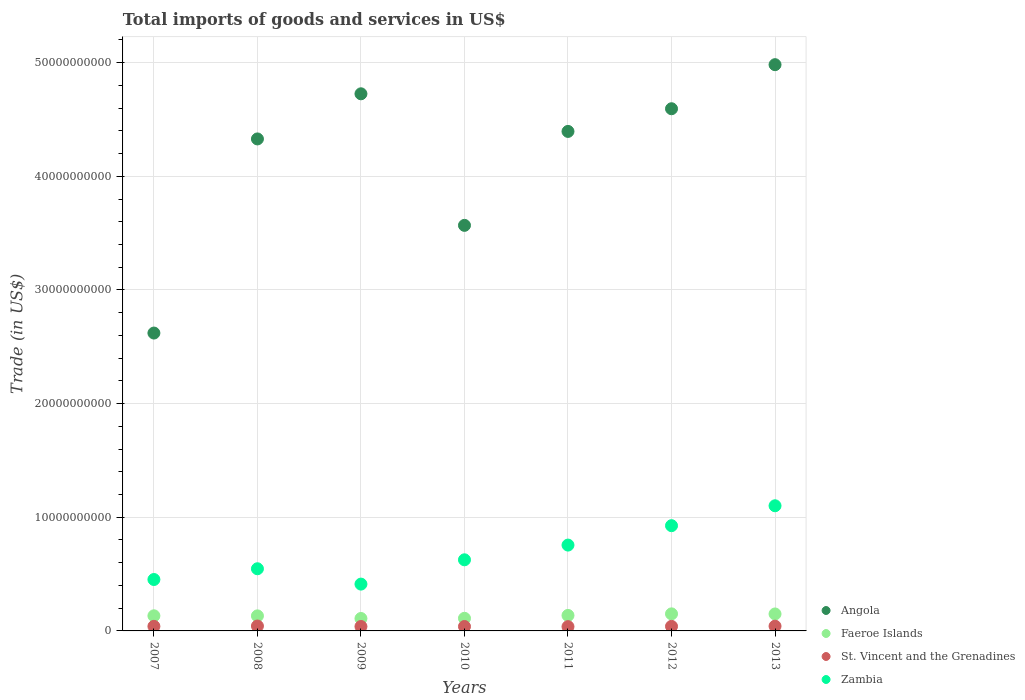Is the number of dotlines equal to the number of legend labels?
Make the answer very short. Yes. What is the total imports of goods and services in Angola in 2012?
Your answer should be very brief. 4.59e+1. Across all years, what is the maximum total imports of goods and services in Faeroe Islands?
Your answer should be compact. 1.50e+09. Across all years, what is the minimum total imports of goods and services in St. Vincent and the Grenadines?
Keep it short and to the point. 3.77e+08. What is the total total imports of goods and services in Zambia in the graph?
Give a very brief answer. 4.82e+1. What is the difference between the total imports of goods and services in Zambia in 2008 and that in 2013?
Your response must be concise. -5.54e+09. What is the difference between the total imports of goods and services in Zambia in 2011 and the total imports of goods and services in Angola in 2010?
Keep it short and to the point. -2.81e+1. What is the average total imports of goods and services in Faeroe Islands per year?
Offer a very short reply. 1.32e+09. In the year 2010, what is the difference between the total imports of goods and services in Faeroe Islands and total imports of goods and services in St. Vincent and the Grenadines?
Give a very brief answer. 7.22e+08. What is the ratio of the total imports of goods and services in Zambia in 2010 to that in 2011?
Offer a very short reply. 0.83. Is the difference between the total imports of goods and services in Faeroe Islands in 2009 and 2010 greater than the difference between the total imports of goods and services in St. Vincent and the Grenadines in 2009 and 2010?
Make the answer very short. No. What is the difference between the highest and the second highest total imports of goods and services in Faeroe Islands?
Provide a succinct answer. 8.29e+06. What is the difference between the highest and the lowest total imports of goods and services in Faeroe Islands?
Your answer should be very brief. 4.08e+08. In how many years, is the total imports of goods and services in St. Vincent and the Grenadines greater than the average total imports of goods and services in St. Vincent and the Grenadines taken over all years?
Give a very brief answer. 4. Is the sum of the total imports of goods and services in Angola in 2008 and 2009 greater than the maximum total imports of goods and services in St. Vincent and the Grenadines across all years?
Your response must be concise. Yes. Is the total imports of goods and services in Faeroe Islands strictly greater than the total imports of goods and services in Zambia over the years?
Your response must be concise. No. Is the total imports of goods and services in Zambia strictly less than the total imports of goods and services in St. Vincent and the Grenadines over the years?
Offer a terse response. No. What is the difference between two consecutive major ticks on the Y-axis?
Keep it short and to the point. 1.00e+1. Does the graph contain any zero values?
Your response must be concise. No. Where does the legend appear in the graph?
Offer a terse response. Bottom right. How are the legend labels stacked?
Make the answer very short. Vertical. What is the title of the graph?
Keep it short and to the point. Total imports of goods and services in US$. Does "Paraguay" appear as one of the legend labels in the graph?
Ensure brevity in your answer.  No. What is the label or title of the Y-axis?
Keep it short and to the point. Trade (in US$). What is the Trade (in US$) of Angola in 2007?
Keep it short and to the point. 2.62e+1. What is the Trade (in US$) of Faeroe Islands in 2007?
Your answer should be very brief. 1.33e+09. What is the Trade (in US$) in St. Vincent and the Grenadines in 2007?
Your answer should be very brief. 4.02e+08. What is the Trade (in US$) in Zambia in 2007?
Your answer should be compact. 4.52e+09. What is the Trade (in US$) in Angola in 2008?
Provide a short and direct response. 4.33e+1. What is the Trade (in US$) in Faeroe Islands in 2008?
Ensure brevity in your answer.  1.32e+09. What is the Trade (in US$) in St. Vincent and the Grenadines in 2008?
Your answer should be compact. 4.31e+08. What is the Trade (in US$) of Zambia in 2008?
Ensure brevity in your answer.  5.47e+09. What is the Trade (in US$) of Angola in 2009?
Give a very brief answer. 4.73e+1. What is the Trade (in US$) in Faeroe Islands in 2009?
Offer a terse response. 1.09e+09. What is the Trade (in US$) in St. Vincent and the Grenadines in 2009?
Make the answer very short. 3.88e+08. What is the Trade (in US$) in Zambia in 2009?
Provide a short and direct response. 4.12e+09. What is the Trade (in US$) of Angola in 2010?
Ensure brevity in your answer.  3.57e+1. What is the Trade (in US$) of Faeroe Islands in 2010?
Ensure brevity in your answer.  1.11e+09. What is the Trade (in US$) of St. Vincent and the Grenadines in 2010?
Your answer should be compact. 3.89e+08. What is the Trade (in US$) of Zambia in 2010?
Give a very brief answer. 6.26e+09. What is the Trade (in US$) in Angola in 2011?
Ensure brevity in your answer.  4.39e+1. What is the Trade (in US$) in Faeroe Islands in 2011?
Your response must be concise. 1.36e+09. What is the Trade (in US$) of St. Vincent and the Grenadines in 2011?
Your answer should be compact. 3.77e+08. What is the Trade (in US$) in Zambia in 2011?
Give a very brief answer. 7.55e+09. What is the Trade (in US$) of Angola in 2012?
Your response must be concise. 4.59e+1. What is the Trade (in US$) of Faeroe Islands in 2012?
Offer a terse response. 1.50e+09. What is the Trade (in US$) in St. Vincent and the Grenadines in 2012?
Your answer should be compact. 4.01e+08. What is the Trade (in US$) in Zambia in 2012?
Give a very brief answer. 9.26e+09. What is the Trade (in US$) of Angola in 2013?
Offer a terse response. 4.98e+1. What is the Trade (in US$) of Faeroe Islands in 2013?
Your answer should be very brief. 1.49e+09. What is the Trade (in US$) in St. Vincent and the Grenadines in 2013?
Your answer should be very brief. 4.18e+08. What is the Trade (in US$) of Zambia in 2013?
Offer a very short reply. 1.10e+1. Across all years, what is the maximum Trade (in US$) of Angola?
Make the answer very short. 4.98e+1. Across all years, what is the maximum Trade (in US$) in Faeroe Islands?
Your answer should be compact. 1.50e+09. Across all years, what is the maximum Trade (in US$) in St. Vincent and the Grenadines?
Offer a very short reply. 4.31e+08. Across all years, what is the maximum Trade (in US$) in Zambia?
Your response must be concise. 1.10e+1. Across all years, what is the minimum Trade (in US$) in Angola?
Offer a terse response. 2.62e+1. Across all years, what is the minimum Trade (in US$) of Faeroe Islands?
Keep it short and to the point. 1.09e+09. Across all years, what is the minimum Trade (in US$) of St. Vincent and the Grenadines?
Ensure brevity in your answer.  3.77e+08. Across all years, what is the minimum Trade (in US$) of Zambia?
Make the answer very short. 4.12e+09. What is the total Trade (in US$) in Angola in the graph?
Your response must be concise. 2.92e+11. What is the total Trade (in US$) of Faeroe Islands in the graph?
Provide a short and direct response. 9.22e+09. What is the total Trade (in US$) of St. Vincent and the Grenadines in the graph?
Provide a succinct answer. 2.81e+09. What is the total Trade (in US$) of Zambia in the graph?
Provide a short and direct response. 4.82e+1. What is the difference between the Trade (in US$) of Angola in 2007 and that in 2008?
Give a very brief answer. -1.71e+1. What is the difference between the Trade (in US$) in Faeroe Islands in 2007 and that in 2008?
Make the answer very short. 6.16e+06. What is the difference between the Trade (in US$) in St. Vincent and the Grenadines in 2007 and that in 2008?
Offer a terse response. -2.87e+07. What is the difference between the Trade (in US$) in Zambia in 2007 and that in 2008?
Give a very brief answer. -9.46e+08. What is the difference between the Trade (in US$) in Angola in 2007 and that in 2009?
Offer a very short reply. -2.10e+1. What is the difference between the Trade (in US$) in Faeroe Islands in 2007 and that in 2009?
Your response must be concise. 2.37e+08. What is the difference between the Trade (in US$) of St. Vincent and the Grenadines in 2007 and that in 2009?
Offer a terse response. 1.41e+07. What is the difference between the Trade (in US$) of Zambia in 2007 and that in 2009?
Your answer should be very brief. 4.05e+08. What is the difference between the Trade (in US$) of Angola in 2007 and that in 2010?
Provide a succinct answer. -9.47e+09. What is the difference between the Trade (in US$) in Faeroe Islands in 2007 and that in 2010?
Offer a very short reply. 2.19e+08. What is the difference between the Trade (in US$) in St. Vincent and the Grenadines in 2007 and that in 2010?
Give a very brief answer. 1.29e+07. What is the difference between the Trade (in US$) of Zambia in 2007 and that in 2010?
Make the answer very short. -1.73e+09. What is the difference between the Trade (in US$) in Angola in 2007 and that in 2011?
Make the answer very short. -1.77e+1. What is the difference between the Trade (in US$) in Faeroe Islands in 2007 and that in 2011?
Your answer should be compact. -3.37e+07. What is the difference between the Trade (in US$) in St. Vincent and the Grenadines in 2007 and that in 2011?
Offer a very short reply. 2.55e+07. What is the difference between the Trade (in US$) in Zambia in 2007 and that in 2011?
Your answer should be very brief. -3.03e+09. What is the difference between the Trade (in US$) of Angola in 2007 and that in 2012?
Offer a terse response. -1.97e+1. What is the difference between the Trade (in US$) of Faeroe Islands in 2007 and that in 2012?
Provide a short and direct response. -1.71e+08. What is the difference between the Trade (in US$) in St. Vincent and the Grenadines in 2007 and that in 2012?
Your response must be concise. 7.20e+05. What is the difference between the Trade (in US$) in Zambia in 2007 and that in 2012?
Your answer should be compact. -4.74e+09. What is the difference between the Trade (in US$) in Angola in 2007 and that in 2013?
Offer a terse response. -2.36e+1. What is the difference between the Trade (in US$) of Faeroe Islands in 2007 and that in 2013?
Provide a short and direct response. -1.63e+08. What is the difference between the Trade (in US$) of St. Vincent and the Grenadines in 2007 and that in 2013?
Your answer should be compact. -1.63e+07. What is the difference between the Trade (in US$) of Zambia in 2007 and that in 2013?
Keep it short and to the point. -6.49e+09. What is the difference between the Trade (in US$) of Angola in 2008 and that in 2009?
Offer a terse response. -3.97e+09. What is the difference between the Trade (in US$) of Faeroe Islands in 2008 and that in 2009?
Give a very brief answer. 2.31e+08. What is the difference between the Trade (in US$) in St. Vincent and the Grenadines in 2008 and that in 2009?
Your answer should be compact. 4.28e+07. What is the difference between the Trade (in US$) of Zambia in 2008 and that in 2009?
Offer a very short reply. 1.35e+09. What is the difference between the Trade (in US$) of Angola in 2008 and that in 2010?
Your answer should be compact. 7.60e+09. What is the difference between the Trade (in US$) in Faeroe Islands in 2008 and that in 2010?
Give a very brief answer. 2.13e+08. What is the difference between the Trade (in US$) of St. Vincent and the Grenadines in 2008 and that in 2010?
Make the answer very short. 4.16e+07. What is the difference between the Trade (in US$) in Zambia in 2008 and that in 2010?
Your answer should be compact. -7.88e+08. What is the difference between the Trade (in US$) of Angola in 2008 and that in 2011?
Your answer should be very brief. -6.61e+08. What is the difference between the Trade (in US$) of Faeroe Islands in 2008 and that in 2011?
Ensure brevity in your answer.  -3.98e+07. What is the difference between the Trade (in US$) in St. Vincent and the Grenadines in 2008 and that in 2011?
Keep it short and to the point. 5.42e+07. What is the difference between the Trade (in US$) in Zambia in 2008 and that in 2011?
Your response must be concise. -2.08e+09. What is the difference between the Trade (in US$) of Angola in 2008 and that in 2012?
Provide a succinct answer. -2.66e+09. What is the difference between the Trade (in US$) of Faeroe Islands in 2008 and that in 2012?
Your response must be concise. -1.77e+08. What is the difference between the Trade (in US$) of St. Vincent and the Grenadines in 2008 and that in 2012?
Give a very brief answer. 2.94e+07. What is the difference between the Trade (in US$) of Zambia in 2008 and that in 2012?
Offer a very short reply. -3.79e+09. What is the difference between the Trade (in US$) of Angola in 2008 and that in 2013?
Ensure brevity in your answer.  -6.53e+09. What is the difference between the Trade (in US$) of Faeroe Islands in 2008 and that in 2013?
Give a very brief answer. -1.69e+08. What is the difference between the Trade (in US$) in St. Vincent and the Grenadines in 2008 and that in 2013?
Give a very brief answer. 1.24e+07. What is the difference between the Trade (in US$) of Zambia in 2008 and that in 2013?
Provide a succinct answer. -5.54e+09. What is the difference between the Trade (in US$) in Angola in 2009 and that in 2010?
Give a very brief answer. 1.16e+1. What is the difference between the Trade (in US$) of Faeroe Islands in 2009 and that in 2010?
Provide a succinct answer. -1.77e+07. What is the difference between the Trade (in US$) of St. Vincent and the Grenadines in 2009 and that in 2010?
Provide a short and direct response. -1.13e+06. What is the difference between the Trade (in US$) in Zambia in 2009 and that in 2010?
Offer a very short reply. -2.14e+09. What is the difference between the Trade (in US$) of Angola in 2009 and that in 2011?
Provide a succinct answer. 3.31e+09. What is the difference between the Trade (in US$) in Faeroe Islands in 2009 and that in 2011?
Your response must be concise. -2.71e+08. What is the difference between the Trade (in US$) in St. Vincent and the Grenadines in 2009 and that in 2011?
Your answer should be very brief. 1.14e+07. What is the difference between the Trade (in US$) in Zambia in 2009 and that in 2011?
Keep it short and to the point. -3.43e+09. What is the difference between the Trade (in US$) of Angola in 2009 and that in 2012?
Your answer should be compact. 1.31e+09. What is the difference between the Trade (in US$) in Faeroe Islands in 2009 and that in 2012?
Offer a very short reply. -4.08e+08. What is the difference between the Trade (in US$) of St. Vincent and the Grenadines in 2009 and that in 2012?
Offer a very short reply. -1.34e+07. What is the difference between the Trade (in US$) of Zambia in 2009 and that in 2012?
Keep it short and to the point. -5.14e+09. What is the difference between the Trade (in US$) of Angola in 2009 and that in 2013?
Offer a very short reply. -2.56e+09. What is the difference between the Trade (in US$) of Faeroe Islands in 2009 and that in 2013?
Offer a very short reply. -4.00e+08. What is the difference between the Trade (in US$) in St. Vincent and the Grenadines in 2009 and that in 2013?
Give a very brief answer. -3.04e+07. What is the difference between the Trade (in US$) in Zambia in 2009 and that in 2013?
Your answer should be very brief. -6.89e+09. What is the difference between the Trade (in US$) in Angola in 2010 and that in 2011?
Your answer should be very brief. -8.27e+09. What is the difference between the Trade (in US$) in Faeroe Islands in 2010 and that in 2011?
Make the answer very short. -2.53e+08. What is the difference between the Trade (in US$) in St. Vincent and the Grenadines in 2010 and that in 2011?
Ensure brevity in your answer.  1.26e+07. What is the difference between the Trade (in US$) of Zambia in 2010 and that in 2011?
Your answer should be very brief. -1.30e+09. What is the difference between the Trade (in US$) in Angola in 2010 and that in 2012?
Ensure brevity in your answer.  -1.03e+1. What is the difference between the Trade (in US$) in Faeroe Islands in 2010 and that in 2012?
Your response must be concise. -3.90e+08. What is the difference between the Trade (in US$) of St. Vincent and the Grenadines in 2010 and that in 2012?
Your answer should be very brief. -1.22e+07. What is the difference between the Trade (in US$) of Zambia in 2010 and that in 2012?
Provide a succinct answer. -3.00e+09. What is the difference between the Trade (in US$) in Angola in 2010 and that in 2013?
Provide a short and direct response. -1.41e+1. What is the difference between the Trade (in US$) in Faeroe Islands in 2010 and that in 2013?
Ensure brevity in your answer.  -3.82e+08. What is the difference between the Trade (in US$) of St. Vincent and the Grenadines in 2010 and that in 2013?
Provide a succinct answer. -2.93e+07. What is the difference between the Trade (in US$) in Zambia in 2010 and that in 2013?
Your response must be concise. -4.75e+09. What is the difference between the Trade (in US$) in Angola in 2011 and that in 2012?
Your response must be concise. -1.99e+09. What is the difference between the Trade (in US$) of Faeroe Islands in 2011 and that in 2012?
Your answer should be very brief. -1.37e+08. What is the difference between the Trade (in US$) of St. Vincent and the Grenadines in 2011 and that in 2012?
Offer a very short reply. -2.48e+07. What is the difference between the Trade (in US$) in Zambia in 2011 and that in 2012?
Your answer should be compact. -1.71e+09. What is the difference between the Trade (in US$) of Angola in 2011 and that in 2013?
Provide a short and direct response. -5.87e+09. What is the difference between the Trade (in US$) in Faeroe Islands in 2011 and that in 2013?
Make the answer very short. -1.29e+08. What is the difference between the Trade (in US$) in St. Vincent and the Grenadines in 2011 and that in 2013?
Keep it short and to the point. -4.18e+07. What is the difference between the Trade (in US$) of Zambia in 2011 and that in 2013?
Ensure brevity in your answer.  -3.46e+09. What is the difference between the Trade (in US$) in Angola in 2012 and that in 2013?
Make the answer very short. -3.88e+09. What is the difference between the Trade (in US$) of Faeroe Islands in 2012 and that in 2013?
Your answer should be compact. 8.29e+06. What is the difference between the Trade (in US$) in St. Vincent and the Grenadines in 2012 and that in 2013?
Ensure brevity in your answer.  -1.70e+07. What is the difference between the Trade (in US$) in Zambia in 2012 and that in 2013?
Your response must be concise. -1.75e+09. What is the difference between the Trade (in US$) in Angola in 2007 and the Trade (in US$) in Faeroe Islands in 2008?
Make the answer very short. 2.49e+1. What is the difference between the Trade (in US$) of Angola in 2007 and the Trade (in US$) of St. Vincent and the Grenadines in 2008?
Keep it short and to the point. 2.58e+1. What is the difference between the Trade (in US$) of Angola in 2007 and the Trade (in US$) of Zambia in 2008?
Make the answer very short. 2.07e+1. What is the difference between the Trade (in US$) in Faeroe Islands in 2007 and the Trade (in US$) in St. Vincent and the Grenadines in 2008?
Offer a terse response. 8.99e+08. What is the difference between the Trade (in US$) in Faeroe Islands in 2007 and the Trade (in US$) in Zambia in 2008?
Provide a short and direct response. -4.14e+09. What is the difference between the Trade (in US$) of St. Vincent and the Grenadines in 2007 and the Trade (in US$) of Zambia in 2008?
Provide a succinct answer. -5.07e+09. What is the difference between the Trade (in US$) of Angola in 2007 and the Trade (in US$) of Faeroe Islands in 2009?
Offer a very short reply. 2.51e+1. What is the difference between the Trade (in US$) in Angola in 2007 and the Trade (in US$) in St. Vincent and the Grenadines in 2009?
Make the answer very short. 2.58e+1. What is the difference between the Trade (in US$) in Angola in 2007 and the Trade (in US$) in Zambia in 2009?
Your response must be concise. 2.21e+1. What is the difference between the Trade (in US$) of Faeroe Islands in 2007 and the Trade (in US$) of St. Vincent and the Grenadines in 2009?
Your answer should be compact. 9.42e+08. What is the difference between the Trade (in US$) in Faeroe Islands in 2007 and the Trade (in US$) in Zambia in 2009?
Your answer should be very brief. -2.79e+09. What is the difference between the Trade (in US$) in St. Vincent and the Grenadines in 2007 and the Trade (in US$) in Zambia in 2009?
Offer a terse response. -3.72e+09. What is the difference between the Trade (in US$) of Angola in 2007 and the Trade (in US$) of Faeroe Islands in 2010?
Give a very brief answer. 2.51e+1. What is the difference between the Trade (in US$) of Angola in 2007 and the Trade (in US$) of St. Vincent and the Grenadines in 2010?
Offer a terse response. 2.58e+1. What is the difference between the Trade (in US$) in Angola in 2007 and the Trade (in US$) in Zambia in 2010?
Your answer should be very brief. 2.00e+1. What is the difference between the Trade (in US$) of Faeroe Islands in 2007 and the Trade (in US$) of St. Vincent and the Grenadines in 2010?
Your answer should be very brief. 9.41e+08. What is the difference between the Trade (in US$) of Faeroe Islands in 2007 and the Trade (in US$) of Zambia in 2010?
Give a very brief answer. -4.93e+09. What is the difference between the Trade (in US$) of St. Vincent and the Grenadines in 2007 and the Trade (in US$) of Zambia in 2010?
Your answer should be very brief. -5.85e+09. What is the difference between the Trade (in US$) in Angola in 2007 and the Trade (in US$) in Faeroe Islands in 2011?
Offer a very short reply. 2.48e+1. What is the difference between the Trade (in US$) of Angola in 2007 and the Trade (in US$) of St. Vincent and the Grenadines in 2011?
Your answer should be compact. 2.58e+1. What is the difference between the Trade (in US$) of Angola in 2007 and the Trade (in US$) of Zambia in 2011?
Your answer should be very brief. 1.87e+1. What is the difference between the Trade (in US$) of Faeroe Islands in 2007 and the Trade (in US$) of St. Vincent and the Grenadines in 2011?
Keep it short and to the point. 9.53e+08. What is the difference between the Trade (in US$) in Faeroe Islands in 2007 and the Trade (in US$) in Zambia in 2011?
Ensure brevity in your answer.  -6.22e+09. What is the difference between the Trade (in US$) of St. Vincent and the Grenadines in 2007 and the Trade (in US$) of Zambia in 2011?
Offer a very short reply. -7.15e+09. What is the difference between the Trade (in US$) in Angola in 2007 and the Trade (in US$) in Faeroe Islands in 2012?
Your answer should be compact. 2.47e+1. What is the difference between the Trade (in US$) of Angola in 2007 and the Trade (in US$) of St. Vincent and the Grenadines in 2012?
Keep it short and to the point. 2.58e+1. What is the difference between the Trade (in US$) in Angola in 2007 and the Trade (in US$) in Zambia in 2012?
Ensure brevity in your answer.  1.69e+1. What is the difference between the Trade (in US$) in Faeroe Islands in 2007 and the Trade (in US$) in St. Vincent and the Grenadines in 2012?
Your response must be concise. 9.29e+08. What is the difference between the Trade (in US$) of Faeroe Islands in 2007 and the Trade (in US$) of Zambia in 2012?
Ensure brevity in your answer.  -7.93e+09. What is the difference between the Trade (in US$) of St. Vincent and the Grenadines in 2007 and the Trade (in US$) of Zambia in 2012?
Provide a succinct answer. -8.86e+09. What is the difference between the Trade (in US$) in Angola in 2007 and the Trade (in US$) in Faeroe Islands in 2013?
Give a very brief answer. 2.47e+1. What is the difference between the Trade (in US$) in Angola in 2007 and the Trade (in US$) in St. Vincent and the Grenadines in 2013?
Give a very brief answer. 2.58e+1. What is the difference between the Trade (in US$) of Angola in 2007 and the Trade (in US$) of Zambia in 2013?
Give a very brief answer. 1.52e+1. What is the difference between the Trade (in US$) of Faeroe Islands in 2007 and the Trade (in US$) of St. Vincent and the Grenadines in 2013?
Ensure brevity in your answer.  9.12e+08. What is the difference between the Trade (in US$) in Faeroe Islands in 2007 and the Trade (in US$) in Zambia in 2013?
Your response must be concise. -9.68e+09. What is the difference between the Trade (in US$) in St. Vincent and the Grenadines in 2007 and the Trade (in US$) in Zambia in 2013?
Offer a very short reply. -1.06e+1. What is the difference between the Trade (in US$) of Angola in 2008 and the Trade (in US$) of Faeroe Islands in 2009?
Give a very brief answer. 4.22e+1. What is the difference between the Trade (in US$) of Angola in 2008 and the Trade (in US$) of St. Vincent and the Grenadines in 2009?
Make the answer very short. 4.29e+1. What is the difference between the Trade (in US$) in Angola in 2008 and the Trade (in US$) in Zambia in 2009?
Ensure brevity in your answer.  3.92e+1. What is the difference between the Trade (in US$) in Faeroe Islands in 2008 and the Trade (in US$) in St. Vincent and the Grenadines in 2009?
Your response must be concise. 9.36e+08. What is the difference between the Trade (in US$) in Faeroe Islands in 2008 and the Trade (in US$) in Zambia in 2009?
Provide a succinct answer. -2.79e+09. What is the difference between the Trade (in US$) in St. Vincent and the Grenadines in 2008 and the Trade (in US$) in Zambia in 2009?
Ensure brevity in your answer.  -3.69e+09. What is the difference between the Trade (in US$) of Angola in 2008 and the Trade (in US$) of Faeroe Islands in 2010?
Your response must be concise. 4.22e+1. What is the difference between the Trade (in US$) in Angola in 2008 and the Trade (in US$) in St. Vincent and the Grenadines in 2010?
Ensure brevity in your answer.  4.29e+1. What is the difference between the Trade (in US$) of Angola in 2008 and the Trade (in US$) of Zambia in 2010?
Your response must be concise. 3.70e+1. What is the difference between the Trade (in US$) of Faeroe Islands in 2008 and the Trade (in US$) of St. Vincent and the Grenadines in 2010?
Your response must be concise. 9.35e+08. What is the difference between the Trade (in US$) of Faeroe Islands in 2008 and the Trade (in US$) of Zambia in 2010?
Offer a very short reply. -4.93e+09. What is the difference between the Trade (in US$) in St. Vincent and the Grenadines in 2008 and the Trade (in US$) in Zambia in 2010?
Ensure brevity in your answer.  -5.83e+09. What is the difference between the Trade (in US$) in Angola in 2008 and the Trade (in US$) in Faeroe Islands in 2011?
Offer a very short reply. 4.19e+1. What is the difference between the Trade (in US$) of Angola in 2008 and the Trade (in US$) of St. Vincent and the Grenadines in 2011?
Offer a terse response. 4.29e+1. What is the difference between the Trade (in US$) of Angola in 2008 and the Trade (in US$) of Zambia in 2011?
Give a very brief answer. 3.57e+1. What is the difference between the Trade (in US$) of Faeroe Islands in 2008 and the Trade (in US$) of St. Vincent and the Grenadines in 2011?
Provide a short and direct response. 9.47e+08. What is the difference between the Trade (in US$) in Faeroe Islands in 2008 and the Trade (in US$) in Zambia in 2011?
Provide a short and direct response. -6.23e+09. What is the difference between the Trade (in US$) of St. Vincent and the Grenadines in 2008 and the Trade (in US$) of Zambia in 2011?
Provide a short and direct response. -7.12e+09. What is the difference between the Trade (in US$) of Angola in 2008 and the Trade (in US$) of Faeroe Islands in 2012?
Provide a short and direct response. 4.18e+1. What is the difference between the Trade (in US$) of Angola in 2008 and the Trade (in US$) of St. Vincent and the Grenadines in 2012?
Ensure brevity in your answer.  4.29e+1. What is the difference between the Trade (in US$) in Angola in 2008 and the Trade (in US$) in Zambia in 2012?
Provide a short and direct response. 3.40e+1. What is the difference between the Trade (in US$) of Faeroe Islands in 2008 and the Trade (in US$) of St. Vincent and the Grenadines in 2012?
Provide a short and direct response. 9.22e+08. What is the difference between the Trade (in US$) in Faeroe Islands in 2008 and the Trade (in US$) in Zambia in 2012?
Provide a succinct answer. -7.94e+09. What is the difference between the Trade (in US$) in St. Vincent and the Grenadines in 2008 and the Trade (in US$) in Zambia in 2012?
Make the answer very short. -8.83e+09. What is the difference between the Trade (in US$) of Angola in 2008 and the Trade (in US$) of Faeroe Islands in 2013?
Provide a short and direct response. 4.18e+1. What is the difference between the Trade (in US$) of Angola in 2008 and the Trade (in US$) of St. Vincent and the Grenadines in 2013?
Offer a very short reply. 4.29e+1. What is the difference between the Trade (in US$) of Angola in 2008 and the Trade (in US$) of Zambia in 2013?
Your response must be concise. 3.23e+1. What is the difference between the Trade (in US$) in Faeroe Islands in 2008 and the Trade (in US$) in St. Vincent and the Grenadines in 2013?
Your response must be concise. 9.05e+08. What is the difference between the Trade (in US$) of Faeroe Islands in 2008 and the Trade (in US$) of Zambia in 2013?
Your response must be concise. -9.69e+09. What is the difference between the Trade (in US$) in St. Vincent and the Grenadines in 2008 and the Trade (in US$) in Zambia in 2013?
Your response must be concise. -1.06e+1. What is the difference between the Trade (in US$) of Angola in 2009 and the Trade (in US$) of Faeroe Islands in 2010?
Keep it short and to the point. 4.61e+1. What is the difference between the Trade (in US$) in Angola in 2009 and the Trade (in US$) in St. Vincent and the Grenadines in 2010?
Your answer should be very brief. 4.69e+1. What is the difference between the Trade (in US$) in Angola in 2009 and the Trade (in US$) in Zambia in 2010?
Your answer should be very brief. 4.10e+1. What is the difference between the Trade (in US$) in Faeroe Islands in 2009 and the Trade (in US$) in St. Vincent and the Grenadines in 2010?
Your answer should be compact. 7.04e+08. What is the difference between the Trade (in US$) in Faeroe Islands in 2009 and the Trade (in US$) in Zambia in 2010?
Offer a very short reply. -5.16e+09. What is the difference between the Trade (in US$) of St. Vincent and the Grenadines in 2009 and the Trade (in US$) of Zambia in 2010?
Your answer should be very brief. -5.87e+09. What is the difference between the Trade (in US$) in Angola in 2009 and the Trade (in US$) in Faeroe Islands in 2011?
Ensure brevity in your answer.  4.59e+1. What is the difference between the Trade (in US$) of Angola in 2009 and the Trade (in US$) of St. Vincent and the Grenadines in 2011?
Provide a short and direct response. 4.69e+1. What is the difference between the Trade (in US$) of Angola in 2009 and the Trade (in US$) of Zambia in 2011?
Offer a terse response. 3.97e+1. What is the difference between the Trade (in US$) of Faeroe Islands in 2009 and the Trade (in US$) of St. Vincent and the Grenadines in 2011?
Provide a succinct answer. 7.16e+08. What is the difference between the Trade (in US$) in Faeroe Islands in 2009 and the Trade (in US$) in Zambia in 2011?
Your answer should be compact. -6.46e+09. What is the difference between the Trade (in US$) in St. Vincent and the Grenadines in 2009 and the Trade (in US$) in Zambia in 2011?
Keep it short and to the point. -7.16e+09. What is the difference between the Trade (in US$) in Angola in 2009 and the Trade (in US$) in Faeroe Islands in 2012?
Offer a very short reply. 4.58e+1. What is the difference between the Trade (in US$) in Angola in 2009 and the Trade (in US$) in St. Vincent and the Grenadines in 2012?
Your answer should be compact. 4.69e+1. What is the difference between the Trade (in US$) of Angola in 2009 and the Trade (in US$) of Zambia in 2012?
Keep it short and to the point. 3.80e+1. What is the difference between the Trade (in US$) of Faeroe Islands in 2009 and the Trade (in US$) of St. Vincent and the Grenadines in 2012?
Your answer should be compact. 6.92e+08. What is the difference between the Trade (in US$) of Faeroe Islands in 2009 and the Trade (in US$) of Zambia in 2012?
Provide a succinct answer. -8.17e+09. What is the difference between the Trade (in US$) in St. Vincent and the Grenadines in 2009 and the Trade (in US$) in Zambia in 2012?
Keep it short and to the point. -8.87e+09. What is the difference between the Trade (in US$) in Angola in 2009 and the Trade (in US$) in Faeroe Islands in 2013?
Provide a succinct answer. 4.58e+1. What is the difference between the Trade (in US$) in Angola in 2009 and the Trade (in US$) in St. Vincent and the Grenadines in 2013?
Your answer should be very brief. 4.68e+1. What is the difference between the Trade (in US$) of Angola in 2009 and the Trade (in US$) of Zambia in 2013?
Provide a short and direct response. 3.62e+1. What is the difference between the Trade (in US$) of Faeroe Islands in 2009 and the Trade (in US$) of St. Vincent and the Grenadines in 2013?
Your answer should be very brief. 6.75e+08. What is the difference between the Trade (in US$) of Faeroe Islands in 2009 and the Trade (in US$) of Zambia in 2013?
Make the answer very short. -9.92e+09. What is the difference between the Trade (in US$) of St. Vincent and the Grenadines in 2009 and the Trade (in US$) of Zambia in 2013?
Offer a terse response. -1.06e+1. What is the difference between the Trade (in US$) of Angola in 2010 and the Trade (in US$) of Faeroe Islands in 2011?
Offer a very short reply. 3.43e+1. What is the difference between the Trade (in US$) of Angola in 2010 and the Trade (in US$) of St. Vincent and the Grenadines in 2011?
Provide a succinct answer. 3.53e+1. What is the difference between the Trade (in US$) of Angola in 2010 and the Trade (in US$) of Zambia in 2011?
Keep it short and to the point. 2.81e+1. What is the difference between the Trade (in US$) in Faeroe Islands in 2010 and the Trade (in US$) in St. Vincent and the Grenadines in 2011?
Offer a terse response. 7.34e+08. What is the difference between the Trade (in US$) in Faeroe Islands in 2010 and the Trade (in US$) in Zambia in 2011?
Your response must be concise. -6.44e+09. What is the difference between the Trade (in US$) of St. Vincent and the Grenadines in 2010 and the Trade (in US$) of Zambia in 2011?
Ensure brevity in your answer.  -7.16e+09. What is the difference between the Trade (in US$) of Angola in 2010 and the Trade (in US$) of Faeroe Islands in 2012?
Your answer should be very brief. 3.42e+1. What is the difference between the Trade (in US$) in Angola in 2010 and the Trade (in US$) in St. Vincent and the Grenadines in 2012?
Your answer should be compact. 3.53e+1. What is the difference between the Trade (in US$) in Angola in 2010 and the Trade (in US$) in Zambia in 2012?
Provide a short and direct response. 2.64e+1. What is the difference between the Trade (in US$) in Faeroe Islands in 2010 and the Trade (in US$) in St. Vincent and the Grenadines in 2012?
Your response must be concise. 7.09e+08. What is the difference between the Trade (in US$) of Faeroe Islands in 2010 and the Trade (in US$) of Zambia in 2012?
Offer a very short reply. -8.15e+09. What is the difference between the Trade (in US$) of St. Vincent and the Grenadines in 2010 and the Trade (in US$) of Zambia in 2012?
Provide a succinct answer. -8.87e+09. What is the difference between the Trade (in US$) in Angola in 2010 and the Trade (in US$) in Faeroe Islands in 2013?
Offer a very short reply. 3.42e+1. What is the difference between the Trade (in US$) of Angola in 2010 and the Trade (in US$) of St. Vincent and the Grenadines in 2013?
Offer a terse response. 3.53e+1. What is the difference between the Trade (in US$) in Angola in 2010 and the Trade (in US$) in Zambia in 2013?
Ensure brevity in your answer.  2.47e+1. What is the difference between the Trade (in US$) in Faeroe Islands in 2010 and the Trade (in US$) in St. Vincent and the Grenadines in 2013?
Your answer should be compact. 6.92e+08. What is the difference between the Trade (in US$) in Faeroe Islands in 2010 and the Trade (in US$) in Zambia in 2013?
Offer a terse response. -9.90e+09. What is the difference between the Trade (in US$) in St. Vincent and the Grenadines in 2010 and the Trade (in US$) in Zambia in 2013?
Offer a terse response. -1.06e+1. What is the difference between the Trade (in US$) of Angola in 2011 and the Trade (in US$) of Faeroe Islands in 2012?
Your response must be concise. 4.24e+1. What is the difference between the Trade (in US$) in Angola in 2011 and the Trade (in US$) in St. Vincent and the Grenadines in 2012?
Provide a succinct answer. 4.35e+1. What is the difference between the Trade (in US$) in Angola in 2011 and the Trade (in US$) in Zambia in 2012?
Your response must be concise. 3.47e+1. What is the difference between the Trade (in US$) in Faeroe Islands in 2011 and the Trade (in US$) in St. Vincent and the Grenadines in 2012?
Offer a terse response. 9.62e+08. What is the difference between the Trade (in US$) of Faeroe Islands in 2011 and the Trade (in US$) of Zambia in 2012?
Keep it short and to the point. -7.90e+09. What is the difference between the Trade (in US$) in St. Vincent and the Grenadines in 2011 and the Trade (in US$) in Zambia in 2012?
Your answer should be very brief. -8.88e+09. What is the difference between the Trade (in US$) of Angola in 2011 and the Trade (in US$) of Faeroe Islands in 2013?
Provide a succinct answer. 4.25e+1. What is the difference between the Trade (in US$) of Angola in 2011 and the Trade (in US$) of St. Vincent and the Grenadines in 2013?
Keep it short and to the point. 4.35e+1. What is the difference between the Trade (in US$) in Angola in 2011 and the Trade (in US$) in Zambia in 2013?
Offer a very short reply. 3.29e+1. What is the difference between the Trade (in US$) of Faeroe Islands in 2011 and the Trade (in US$) of St. Vincent and the Grenadines in 2013?
Give a very brief answer. 9.45e+08. What is the difference between the Trade (in US$) of Faeroe Islands in 2011 and the Trade (in US$) of Zambia in 2013?
Keep it short and to the point. -9.65e+09. What is the difference between the Trade (in US$) in St. Vincent and the Grenadines in 2011 and the Trade (in US$) in Zambia in 2013?
Make the answer very short. -1.06e+1. What is the difference between the Trade (in US$) of Angola in 2012 and the Trade (in US$) of Faeroe Islands in 2013?
Make the answer very short. 4.44e+1. What is the difference between the Trade (in US$) in Angola in 2012 and the Trade (in US$) in St. Vincent and the Grenadines in 2013?
Offer a very short reply. 4.55e+1. What is the difference between the Trade (in US$) in Angola in 2012 and the Trade (in US$) in Zambia in 2013?
Your answer should be compact. 3.49e+1. What is the difference between the Trade (in US$) in Faeroe Islands in 2012 and the Trade (in US$) in St. Vincent and the Grenadines in 2013?
Your answer should be very brief. 1.08e+09. What is the difference between the Trade (in US$) of Faeroe Islands in 2012 and the Trade (in US$) of Zambia in 2013?
Offer a very short reply. -9.51e+09. What is the difference between the Trade (in US$) of St. Vincent and the Grenadines in 2012 and the Trade (in US$) of Zambia in 2013?
Make the answer very short. -1.06e+1. What is the average Trade (in US$) in Angola per year?
Make the answer very short. 4.17e+1. What is the average Trade (in US$) in Faeroe Islands per year?
Your answer should be compact. 1.32e+09. What is the average Trade (in US$) in St. Vincent and the Grenadines per year?
Give a very brief answer. 4.01e+08. What is the average Trade (in US$) of Zambia per year?
Keep it short and to the point. 6.88e+09. In the year 2007, what is the difference between the Trade (in US$) in Angola and Trade (in US$) in Faeroe Islands?
Provide a short and direct response. 2.49e+1. In the year 2007, what is the difference between the Trade (in US$) in Angola and Trade (in US$) in St. Vincent and the Grenadines?
Your answer should be very brief. 2.58e+1. In the year 2007, what is the difference between the Trade (in US$) of Angola and Trade (in US$) of Zambia?
Offer a terse response. 2.17e+1. In the year 2007, what is the difference between the Trade (in US$) of Faeroe Islands and Trade (in US$) of St. Vincent and the Grenadines?
Provide a short and direct response. 9.28e+08. In the year 2007, what is the difference between the Trade (in US$) of Faeroe Islands and Trade (in US$) of Zambia?
Provide a short and direct response. -3.19e+09. In the year 2007, what is the difference between the Trade (in US$) of St. Vincent and the Grenadines and Trade (in US$) of Zambia?
Give a very brief answer. -4.12e+09. In the year 2008, what is the difference between the Trade (in US$) in Angola and Trade (in US$) in Faeroe Islands?
Give a very brief answer. 4.20e+1. In the year 2008, what is the difference between the Trade (in US$) of Angola and Trade (in US$) of St. Vincent and the Grenadines?
Provide a succinct answer. 4.29e+1. In the year 2008, what is the difference between the Trade (in US$) in Angola and Trade (in US$) in Zambia?
Offer a terse response. 3.78e+1. In the year 2008, what is the difference between the Trade (in US$) of Faeroe Islands and Trade (in US$) of St. Vincent and the Grenadines?
Your response must be concise. 8.93e+08. In the year 2008, what is the difference between the Trade (in US$) of Faeroe Islands and Trade (in US$) of Zambia?
Provide a short and direct response. -4.15e+09. In the year 2008, what is the difference between the Trade (in US$) of St. Vincent and the Grenadines and Trade (in US$) of Zambia?
Your response must be concise. -5.04e+09. In the year 2009, what is the difference between the Trade (in US$) in Angola and Trade (in US$) in Faeroe Islands?
Ensure brevity in your answer.  4.62e+1. In the year 2009, what is the difference between the Trade (in US$) in Angola and Trade (in US$) in St. Vincent and the Grenadines?
Offer a terse response. 4.69e+1. In the year 2009, what is the difference between the Trade (in US$) in Angola and Trade (in US$) in Zambia?
Make the answer very short. 4.31e+1. In the year 2009, what is the difference between the Trade (in US$) in Faeroe Islands and Trade (in US$) in St. Vincent and the Grenadines?
Your answer should be very brief. 7.05e+08. In the year 2009, what is the difference between the Trade (in US$) of Faeroe Islands and Trade (in US$) of Zambia?
Offer a very short reply. -3.03e+09. In the year 2009, what is the difference between the Trade (in US$) of St. Vincent and the Grenadines and Trade (in US$) of Zambia?
Your answer should be very brief. -3.73e+09. In the year 2010, what is the difference between the Trade (in US$) in Angola and Trade (in US$) in Faeroe Islands?
Offer a very short reply. 3.46e+1. In the year 2010, what is the difference between the Trade (in US$) of Angola and Trade (in US$) of St. Vincent and the Grenadines?
Offer a very short reply. 3.53e+1. In the year 2010, what is the difference between the Trade (in US$) in Angola and Trade (in US$) in Zambia?
Offer a terse response. 2.94e+1. In the year 2010, what is the difference between the Trade (in US$) in Faeroe Islands and Trade (in US$) in St. Vincent and the Grenadines?
Ensure brevity in your answer.  7.22e+08. In the year 2010, what is the difference between the Trade (in US$) of Faeroe Islands and Trade (in US$) of Zambia?
Offer a terse response. -5.15e+09. In the year 2010, what is the difference between the Trade (in US$) of St. Vincent and the Grenadines and Trade (in US$) of Zambia?
Provide a short and direct response. -5.87e+09. In the year 2011, what is the difference between the Trade (in US$) of Angola and Trade (in US$) of Faeroe Islands?
Your answer should be very brief. 4.26e+1. In the year 2011, what is the difference between the Trade (in US$) in Angola and Trade (in US$) in St. Vincent and the Grenadines?
Ensure brevity in your answer.  4.36e+1. In the year 2011, what is the difference between the Trade (in US$) of Angola and Trade (in US$) of Zambia?
Make the answer very short. 3.64e+1. In the year 2011, what is the difference between the Trade (in US$) of Faeroe Islands and Trade (in US$) of St. Vincent and the Grenadines?
Ensure brevity in your answer.  9.87e+08. In the year 2011, what is the difference between the Trade (in US$) of Faeroe Islands and Trade (in US$) of Zambia?
Your answer should be compact. -6.19e+09. In the year 2011, what is the difference between the Trade (in US$) of St. Vincent and the Grenadines and Trade (in US$) of Zambia?
Offer a terse response. -7.18e+09. In the year 2012, what is the difference between the Trade (in US$) in Angola and Trade (in US$) in Faeroe Islands?
Provide a succinct answer. 4.44e+1. In the year 2012, what is the difference between the Trade (in US$) of Angola and Trade (in US$) of St. Vincent and the Grenadines?
Your answer should be very brief. 4.55e+1. In the year 2012, what is the difference between the Trade (in US$) in Angola and Trade (in US$) in Zambia?
Provide a succinct answer. 3.67e+1. In the year 2012, what is the difference between the Trade (in US$) of Faeroe Islands and Trade (in US$) of St. Vincent and the Grenadines?
Make the answer very short. 1.10e+09. In the year 2012, what is the difference between the Trade (in US$) in Faeroe Islands and Trade (in US$) in Zambia?
Give a very brief answer. -7.76e+09. In the year 2012, what is the difference between the Trade (in US$) in St. Vincent and the Grenadines and Trade (in US$) in Zambia?
Your answer should be compact. -8.86e+09. In the year 2013, what is the difference between the Trade (in US$) in Angola and Trade (in US$) in Faeroe Islands?
Provide a short and direct response. 4.83e+1. In the year 2013, what is the difference between the Trade (in US$) of Angola and Trade (in US$) of St. Vincent and the Grenadines?
Offer a terse response. 4.94e+1. In the year 2013, what is the difference between the Trade (in US$) in Angola and Trade (in US$) in Zambia?
Offer a terse response. 3.88e+1. In the year 2013, what is the difference between the Trade (in US$) in Faeroe Islands and Trade (in US$) in St. Vincent and the Grenadines?
Offer a very short reply. 1.07e+09. In the year 2013, what is the difference between the Trade (in US$) in Faeroe Islands and Trade (in US$) in Zambia?
Provide a succinct answer. -9.52e+09. In the year 2013, what is the difference between the Trade (in US$) in St. Vincent and the Grenadines and Trade (in US$) in Zambia?
Provide a succinct answer. -1.06e+1. What is the ratio of the Trade (in US$) in Angola in 2007 to that in 2008?
Ensure brevity in your answer.  0.61. What is the ratio of the Trade (in US$) in St. Vincent and the Grenadines in 2007 to that in 2008?
Provide a short and direct response. 0.93. What is the ratio of the Trade (in US$) of Zambia in 2007 to that in 2008?
Ensure brevity in your answer.  0.83. What is the ratio of the Trade (in US$) in Angola in 2007 to that in 2009?
Make the answer very short. 0.55. What is the ratio of the Trade (in US$) in Faeroe Islands in 2007 to that in 2009?
Offer a terse response. 1.22. What is the ratio of the Trade (in US$) of St. Vincent and the Grenadines in 2007 to that in 2009?
Keep it short and to the point. 1.04. What is the ratio of the Trade (in US$) in Zambia in 2007 to that in 2009?
Keep it short and to the point. 1.1. What is the ratio of the Trade (in US$) in Angola in 2007 to that in 2010?
Provide a short and direct response. 0.73. What is the ratio of the Trade (in US$) of Faeroe Islands in 2007 to that in 2010?
Your answer should be very brief. 1.2. What is the ratio of the Trade (in US$) in St. Vincent and the Grenadines in 2007 to that in 2010?
Give a very brief answer. 1.03. What is the ratio of the Trade (in US$) in Zambia in 2007 to that in 2010?
Your answer should be compact. 0.72. What is the ratio of the Trade (in US$) of Angola in 2007 to that in 2011?
Give a very brief answer. 0.6. What is the ratio of the Trade (in US$) in Faeroe Islands in 2007 to that in 2011?
Ensure brevity in your answer.  0.98. What is the ratio of the Trade (in US$) of St. Vincent and the Grenadines in 2007 to that in 2011?
Make the answer very short. 1.07. What is the ratio of the Trade (in US$) in Zambia in 2007 to that in 2011?
Make the answer very short. 0.6. What is the ratio of the Trade (in US$) in Angola in 2007 to that in 2012?
Ensure brevity in your answer.  0.57. What is the ratio of the Trade (in US$) of Faeroe Islands in 2007 to that in 2012?
Your response must be concise. 0.89. What is the ratio of the Trade (in US$) in St. Vincent and the Grenadines in 2007 to that in 2012?
Offer a terse response. 1. What is the ratio of the Trade (in US$) in Zambia in 2007 to that in 2012?
Offer a terse response. 0.49. What is the ratio of the Trade (in US$) of Angola in 2007 to that in 2013?
Your answer should be very brief. 0.53. What is the ratio of the Trade (in US$) in Faeroe Islands in 2007 to that in 2013?
Your answer should be compact. 0.89. What is the ratio of the Trade (in US$) of St. Vincent and the Grenadines in 2007 to that in 2013?
Provide a succinct answer. 0.96. What is the ratio of the Trade (in US$) of Zambia in 2007 to that in 2013?
Keep it short and to the point. 0.41. What is the ratio of the Trade (in US$) in Angola in 2008 to that in 2009?
Keep it short and to the point. 0.92. What is the ratio of the Trade (in US$) of Faeroe Islands in 2008 to that in 2009?
Ensure brevity in your answer.  1.21. What is the ratio of the Trade (in US$) in St. Vincent and the Grenadines in 2008 to that in 2009?
Offer a terse response. 1.11. What is the ratio of the Trade (in US$) of Zambia in 2008 to that in 2009?
Your response must be concise. 1.33. What is the ratio of the Trade (in US$) in Angola in 2008 to that in 2010?
Ensure brevity in your answer.  1.21. What is the ratio of the Trade (in US$) of Faeroe Islands in 2008 to that in 2010?
Offer a terse response. 1.19. What is the ratio of the Trade (in US$) of St. Vincent and the Grenadines in 2008 to that in 2010?
Your answer should be compact. 1.11. What is the ratio of the Trade (in US$) in Zambia in 2008 to that in 2010?
Your response must be concise. 0.87. What is the ratio of the Trade (in US$) of Angola in 2008 to that in 2011?
Your response must be concise. 0.98. What is the ratio of the Trade (in US$) in Faeroe Islands in 2008 to that in 2011?
Keep it short and to the point. 0.97. What is the ratio of the Trade (in US$) of St. Vincent and the Grenadines in 2008 to that in 2011?
Provide a succinct answer. 1.14. What is the ratio of the Trade (in US$) of Zambia in 2008 to that in 2011?
Your answer should be compact. 0.72. What is the ratio of the Trade (in US$) in Angola in 2008 to that in 2012?
Keep it short and to the point. 0.94. What is the ratio of the Trade (in US$) of Faeroe Islands in 2008 to that in 2012?
Ensure brevity in your answer.  0.88. What is the ratio of the Trade (in US$) of St. Vincent and the Grenadines in 2008 to that in 2012?
Your response must be concise. 1.07. What is the ratio of the Trade (in US$) in Zambia in 2008 to that in 2012?
Your answer should be very brief. 0.59. What is the ratio of the Trade (in US$) of Angola in 2008 to that in 2013?
Ensure brevity in your answer.  0.87. What is the ratio of the Trade (in US$) of Faeroe Islands in 2008 to that in 2013?
Make the answer very short. 0.89. What is the ratio of the Trade (in US$) of St. Vincent and the Grenadines in 2008 to that in 2013?
Make the answer very short. 1.03. What is the ratio of the Trade (in US$) of Zambia in 2008 to that in 2013?
Ensure brevity in your answer.  0.5. What is the ratio of the Trade (in US$) of Angola in 2009 to that in 2010?
Offer a very short reply. 1.32. What is the ratio of the Trade (in US$) in Faeroe Islands in 2009 to that in 2010?
Your response must be concise. 0.98. What is the ratio of the Trade (in US$) in Zambia in 2009 to that in 2010?
Your answer should be very brief. 0.66. What is the ratio of the Trade (in US$) of Angola in 2009 to that in 2011?
Make the answer very short. 1.08. What is the ratio of the Trade (in US$) in Faeroe Islands in 2009 to that in 2011?
Your answer should be compact. 0.8. What is the ratio of the Trade (in US$) in St. Vincent and the Grenadines in 2009 to that in 2011?
Your response must be concise. 1.03. What is the ratio of the Trade (in US$) in Zambia in 2009 to that in 2011?
Your answer should be very brief. 0.55. What is the ratio of the Trade (in US$) of Angola in 2009 to that in 2012?
Provide a succinct answer. 1.03. What is the ratio of the Trade (in US$) in Faeroe Islands in 2009 to that in 2012?
Provide a short and direct response. 0.73. What is the ratio of the Trade (in US$) in St. Vincent and the Grenadines in 2009 to that in 2012?
Make the answer very short. 0.97. What is the ratio of the Trade (in US$) in Zambia in 2009 to that in 2012?
Make the answer very short. 0.44. What is the ratio of the Trade (in US$) in Angola in 2009 to that in 2013?
Make the answer very short. 0.95. What is the ratio of the Trade (in US$) in Faeroe Islands in 2009 to that in 2013?
Ensure brevity in your answer.  0.73. What is the ratio of the Trade (in US$) in St. Vincent and the Grenadines in 2009 to that in 2013?
Your answer should be very brief. 0.93. What is the ratio of the Trade (in US$) in Zambia in 2009 to that in 2013?
Provide a short and direct response. 0.37. What is the ratio of the Trade (in US$) in Angola in 2010 to that in 2011?
Provide a succinct answer. 0.81. What is the ratio of the Trade (in US$) in Faeroe Islands in 2010 to that in 2011?
Your response must be concise. 0.81. What is the ratio of the Trade (in US$) in St. Vincent and the Grenadines in 2010 to that in 2011?
Your response must be concise. 1.03. What is the ratio of the Trade (in US$) of Zambia in 2010 to that in 2011?
Offer a very short reply. 0.83. What is the ratio of the Trade (in US$) of Angola in 2010 to that in 2012?
Keep it short and to the point. 0.78. What is the ratio of the Trade (in US$) of Faeroe Islands in 2010 to that in 2012?
Your answer should be very brief. 0.74. What is the ratio of the Trade (in US$) in St. Vincent and the Grenadines in 2010 to that in 2012?
Your answer should be compact. 0.97. What is the ratio of the Trade (in US$) of Zambia in 2010 to that in 2012?
Offer a very short reply. 0.68. What is the ratio of the Trade (in US$) in Angola in 2010 to that in 2013?
Give a very brief answer. 0.72. What is the ratio of the Trade (in US$) of Faeroe Islands in 2010 to that in 2013?
Your answer should be very brief. 0.74. What is the ratio of the Trade (in US$) in St. Vincent and the Grenadines in 2010 to that in 2013?
Keep it short and to the point. 0.93. What is the ratio of the Trade (in US$) of Zambia in 2010 to that in 2013?
Ensure brevity in your answer.  0.57. What is the ratio of the Trade (in US$) in Angola in 2011 to that in 2012?
Provide a succinct answer. 0.96. What is the ratio of the Trade (in US$) of Faeroe Islands in 2011 to that in 2012?
Keep it short and to the point. 0.91. What is the ratio of the Trade (in US$) of St. Vincent and the Grenadines in 2011 to that in 2012?
Provide a short and direct response. 0.94. What is the ratio of the Trade (in US$) in Zambia in 2011 to that in 2012?
Keep it short and to the point. 0.82. What is the ratio of the Trade (in US$) in Angola in 2011 to that in 2013?
Offer a terse response. 0.88. What is the ratio of the Trade (in US$) of Faeroe Islands in 2011 to that in 2013?
Provide a succinct answer. 0.91. What is the ratio of the Trade (in US$) in St. Vincent and the Grenadines in 2011 to that in 2013?
Give a very brief answer. 0.9. What is the ratio of the Trade (in US$) of Zambia in 2011 to that in 2013?
Provide a short and direct response. 0.69. What is the ratio of the Trade (in US$) in Angola in 2012 to that in 2013?
Offer a terse response. 0.92. What is the ratio of the Trade (in US$) in Faeroe Islands in 2012 to that in 2013?
Provide a short and direct response. 1.01. What is the ratio of the Trade (in US$) of St. Vincent and the Grenadines in 2012 to that in 2013?
Your answer should be very brief. 0.96. What is the ratio of the Trade (in US$) of Zambia in 2012 to that in 2013?
Give a very brief answer. 0.84. What is the difference between the highest and the second highest Trade (in US$) of Angola?
Make the answer very short. 2.56e+09. What is the difference between the highest and the second highest Trade (in US$) of Faeroe Islands?
Your answer should be very brief. 8.29e+06. What is the difference between the highest and the second highest Trade (in US$) in St. Vincent and the Grenadines?
Your answer should be very brief. 1.24e+07. What is the difference between the highest and the second highest Trade (in US$) of Zambia?
Your answer should be very brief. 1.75e+09. What is the difference between the highest and the lowest Trade (in US$) of Angola?
Provide a short and direct response. 2.36e+1. What is the difference between the highest and the lowest Trade (in US$) in Faeroe Islands?
Give a very brief answer. 4.08e+08. What is the difference between the highest and the lowest Trade (in US$) of St. Vincent and the Grenadines?
Make the answer very short. 5.42e+07. What is the difference between the highest and the lowest Trade (in US$) of Zambia?
Give a very brief answer. 6.89e+09. 